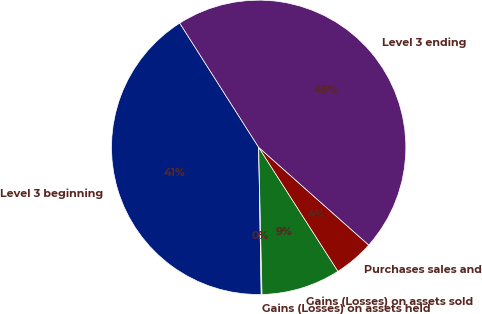Convert chart to OTSL. <chart><loc_0><loc_0><loc_500><loc_500><pie_chart><fcel>Level 3 beginning<fcel>Gains (Losses) on assets held<fcel>Gains (Losses) on assets sold<fcel>Purchases sales and<fcel>Level 3 ending<nl><fcel>41.26%<fcel>0.09%<fcel>8.69%<fcel>4.39%<fcel>45.56%<nl></chart> 